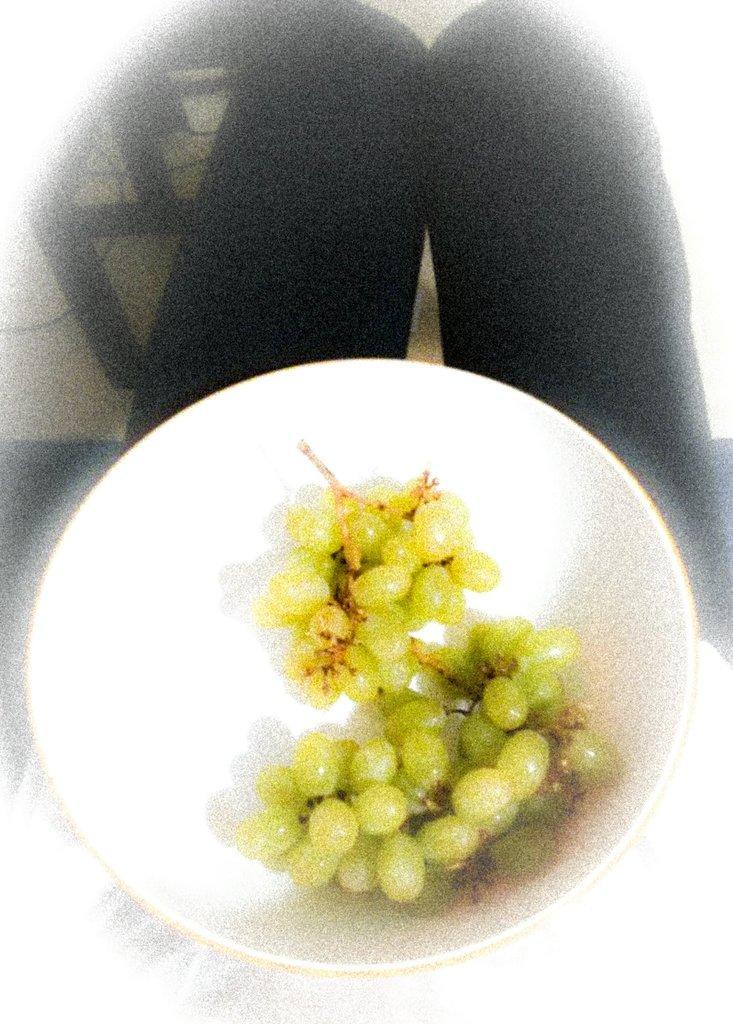Please provide a concise description of this image. This image is taken indoors. At the bottom of the image taken indoors. In the middle of the image there is a bowl with grapes in it. At the top of the image there is a chair on the floor. 